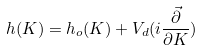<formula> <loc_0><loc_0><loc_500><loc_500>h ( K ) = h _ { o } ( K ) + V _ { d } ( i \frac { \vec { \partial } } { \partial K } )</formula> 